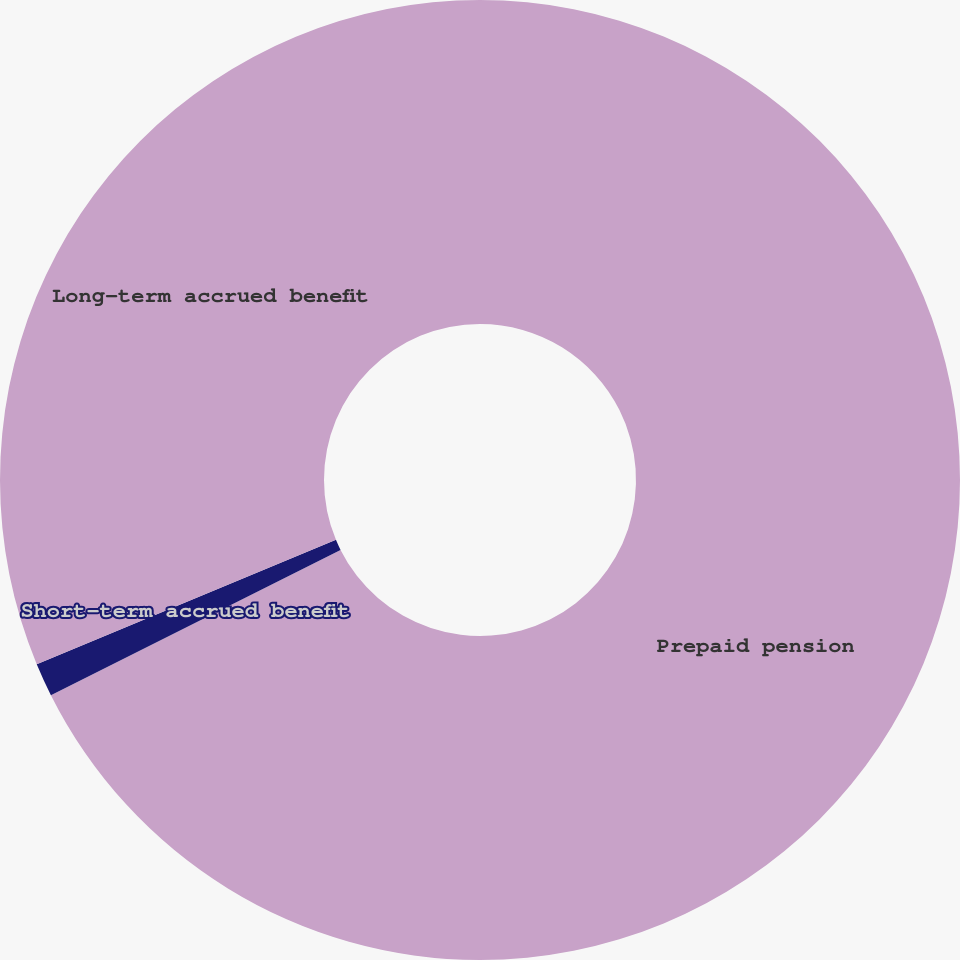<chart> <loc_0><loc_0><loc_500><loc_500><pie_chart><fcel>Prepaid pension<fcel>Short-term accrued benefit<fcel>Long-term accrued benefit<nl><fcel>67.61%<fcel>1.13%<fcel>31.27%<nl></chart> 